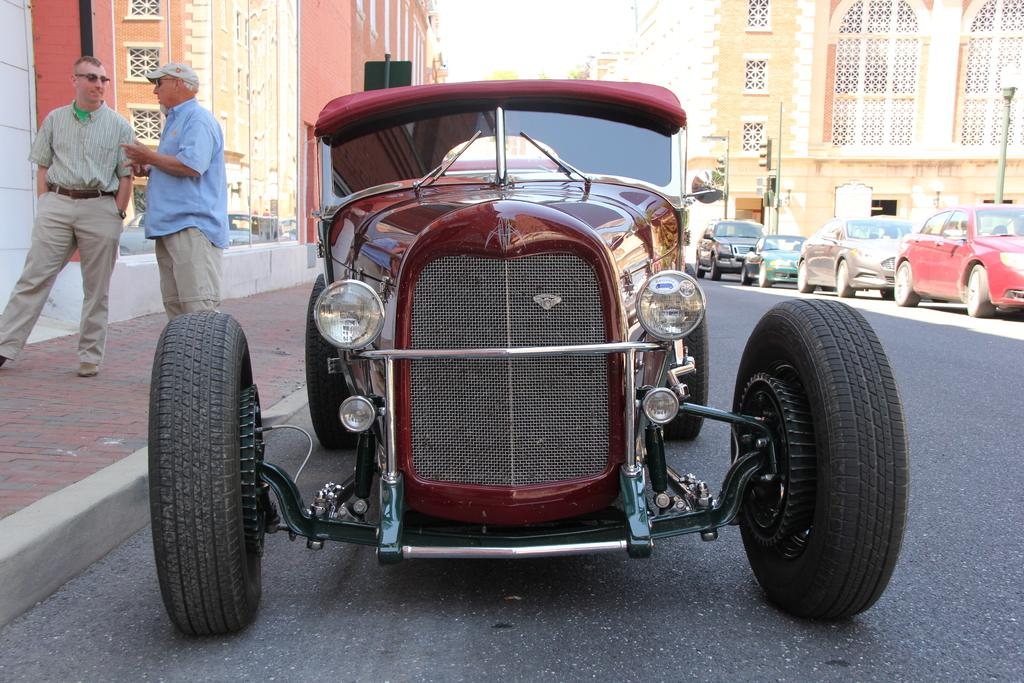What can be seen on the left side of the image? There are two persons on a footpath on the left side of the image. What is happening on the road in the image? There are vehicles of different colors on the road. What is visible on both sides of the road? There are buildings on both sides of the road. How many girls are present in the image? There is no mention of girls in the provided facts, so we cannot determine the number of girls in the image. What design can be seen on the footpath in the image? The provided facts do not mention any specific design on the footpath, so we cannot describe it. 